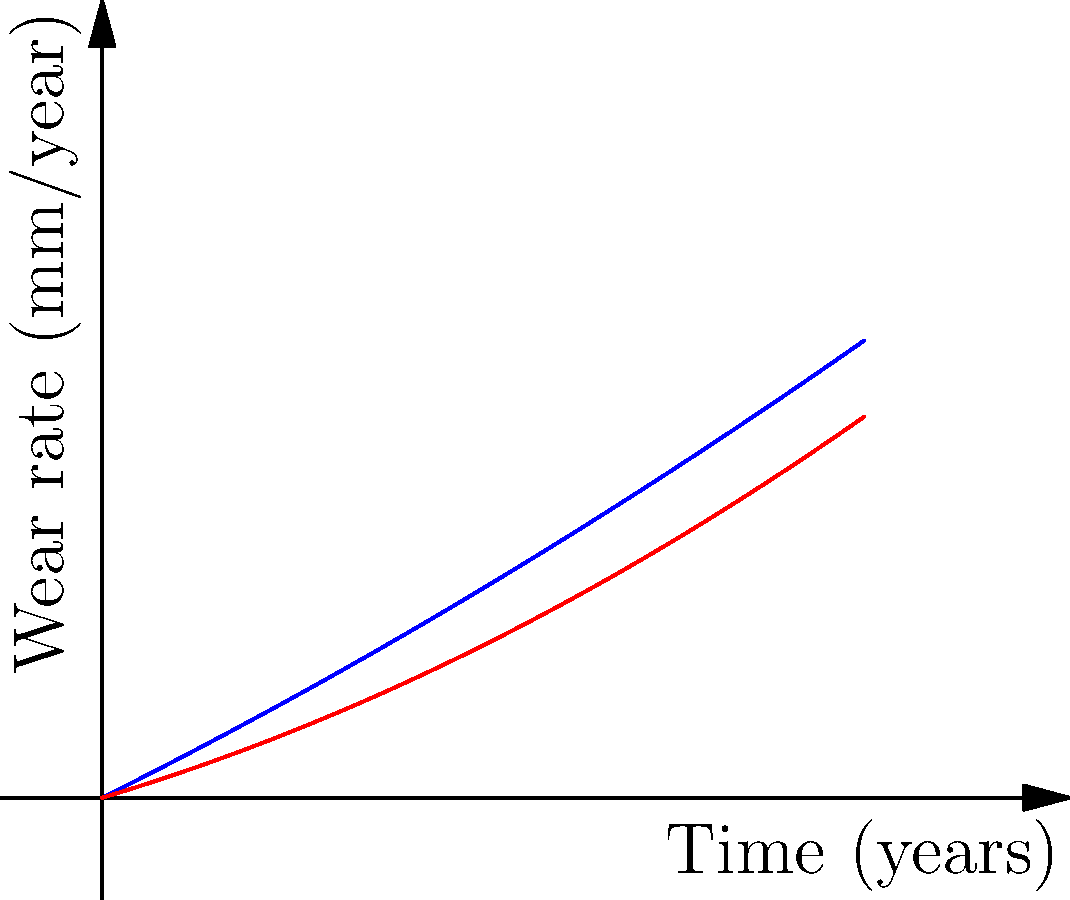As a supplier representative working with quality control, you're analyzing wear patterns of different joint replacement materials over time. The graph shows wear rates for ceramic-on-ceramic and metal-on-polyethylene combinations. After 5 years, what is the approximate difference in wear rate between these two material combinations? To solve this problem, we need to follow these steps:

1. Identify the curves:
   - Blue curve: Ceramic-on-Ceramic
   - Red curve: Metal-on-Polyethylene

2. Find the wear rate for each material at 5 years:
   - Ceramic-on-Ceramic (blue curve): 
     At x = 5, y ≈ 3.0 mm/year
   - Metal-on-Polyethylene (red curve): 
     At x = 5, y ≈ 2.0 mm/year

3. Calculate the difference in wear rate:
   Difference = Ceramic-on-Ceramic rate - Metal-on-Polyethylene rate
               ≈ 3.0 mm/year - 2.0 mm/year
               ≈ 1.0 mm/year

Therefore, after 5 years, the ceramic-on-ceramic combination has a wear rate approximately 1.0 mm/year higher than the metal-on-polyethylene combination.
Answer: 1.0 mm/year 